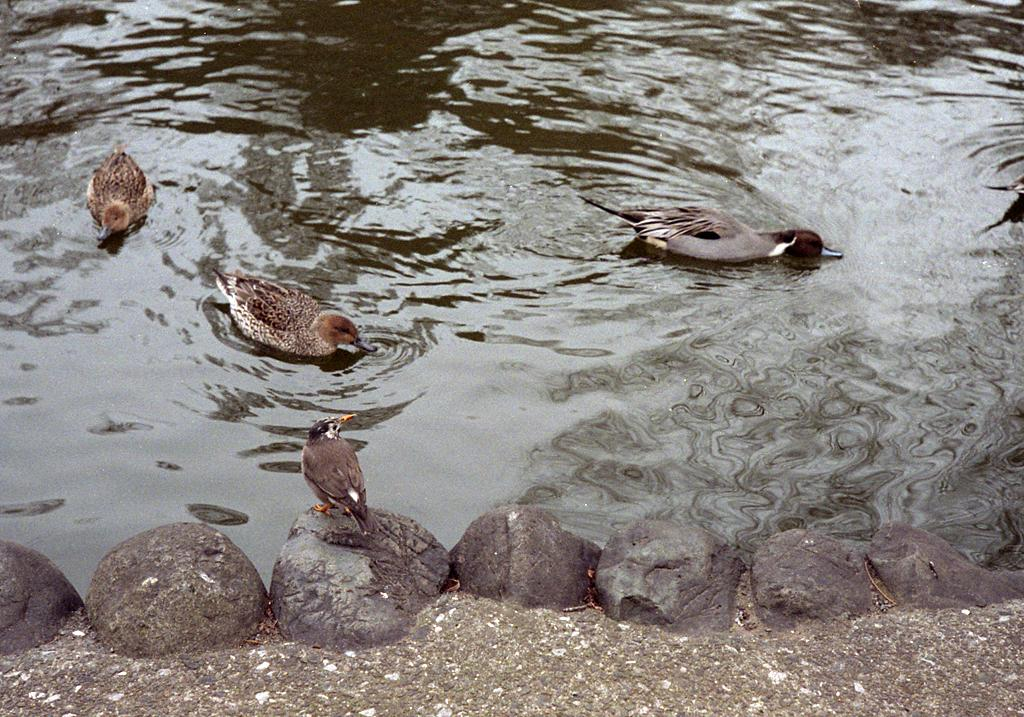What is the main feature of the image? There is a water body in the image. What can be seen in the water body? There are birds in the water body. What are the birds doing in the image? One bird is drinking water, and one bird is standing on rocks. What type of nut is the bird holding in its beak? There is no nut present in the image; the bird is drinking water and standing on rocks. 